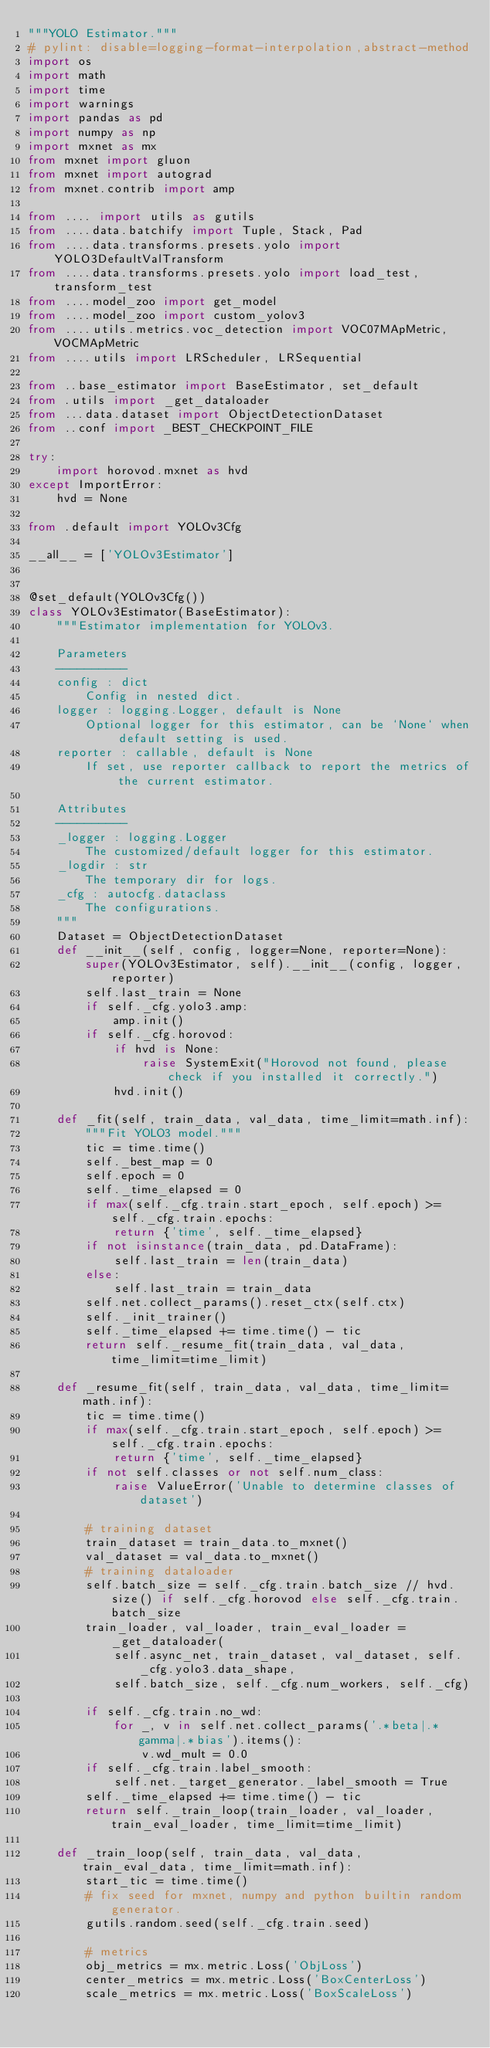<code> <loc_0><loc_0><loc_500><loc_500><_Python_>"""YOLO Estimator."""
# pylint: disable=logging-format-interpolation,abstract-method
import os
import math
import time
import warnings
import pandas as pd
import numpy as np
import mxnet as mx
from mxnet import gluon
from mxnet import autograd
from mxnet.contrib import amp

from .... import utils as gutils
from ....data.batchify import Tuple, Stack, Pad
from ....data.transforms.presets.yolo import YOLO3DefaultValTransform
from ....data.transforms.presets.yolo import load_test, transform_test
from ....model_zoo import get_model
from ....model_zoo import custom_yolov3
from ....utils.metrics.voc_detection import VOC07MApMetric, VOCMApMetric
from ....utils import LRScheduler, LRSequential

from ..base_estimator import BaseEstimator, set_default
from .utils import _get_dataloader
from ...data.dataset import ObjectDetectionDataset
from ..conf import _BEST_CHECKPOINT_FILE

try:
    import horovod.mxnet as hvd
except ImportError:
    hvd = None

from .default import YOLOv3Cfg

__all__ = ['YOLOv3Estimator']


@set_default(YOLOv3Cfg())
class YOLOv3Estimator(BaseEstimator):
    """Estimator implementation for YOLOv3.

    Parameters
    ----------
    config : dict
        Config in nested dict.
    logger : logging.Logger, default is None
        Optional logger for this estimator, can be `None` when default setting is used.
    reporter : callable, default is None
        If set, use reporter callback to report the metrics of the current estimator.

    Attributes
    ----------
    _logger : logging.Logger
        The customized/default logger for this estimator.
    _logdir : str
        The temporary dir for logs.
    _cfg : autocfg.dataclass
        The configurations.
    """
    Dataset = ObjectDetectionDataset
    def __init__(self, config, logger=None, reporter=None):
        super(YOLOv3Estimator, self).__init__(config, logger, reporter)
        self.last_train = None
        if self._cfg.yolo3.amp:
            amp.init()
        if self._cfg.horovod:
            if hvd is None:
                raise SystemExit("Horovod not found, please check if you installed it correctly.")
            hvd.init()

    def _fit(self, train_data, val_data, time_limit=math.inf):
        """Fit YOLO3 model."""
        tic = time.time()
        self._best_map = 0
        self.epoch = 0
        self._time_elapsed = 0
        if max(self._cfg.train.start_epoch, self.epoch) >= self._cfg.train.epochs:
            return {'time', self._time_elapsed}
        if not isinstance(train_data, pd.DataFrame):
            self.last_train = len(train_data)
        else:
            self.last_train = train_data
        self.net.collect_params().reset_ctx(self.ctx)
        self._init_trainer()
        self._time_elapsed += time.time() - tic
        return self._resume_fit(train_data, val_data, time_limit=time_limit)

    def _resume_fit(self, train_data, val_data, time_limit=math.inf):
        tic = time.time()
        if max(self._cfg.train.start_epoch, self.epoch) >= self._cfg.train.epochs:
            return {'time', self._time_elapsed}
        if not self.classes or not self.num_class:
            raise ValueError('Unable to determine classes of dataset')

        # training dataset
        train_dataset = train_data.to_mxnet()
        val_dataset = val_data.to_mxnet()
        # training dataloader
        self.batch_size = self._cfg.train.batch_size // hvd.size() if self._cfg.horovod else self._cfg.train.batch_size
        train_loader, val_loader, train_eval_loader = _get_dataloader(
            self.async_net, train_dataset, val_dataset, self._cfg.yolo3.data_shape,
            self.batch_size, self._cfg.num_workers, self._cfg)

        if self._cfg.train.no_wd:
            for _, v in self.net.collect_params('.*beta|.*gamma|.*bias').items():
                v.wd_mult = 0.0
        if self._cfg.train.label_smooth:
            self.net._target_generator._label_smooth = True
        self._time_elapsed += time.time() - tic
        return self._train_loop(train_loader, val_loader, train_eval_loader, time_limit=time_limit)

    def _train_loop(self, train_data, val_data, train_eval_data, time_limit=math.inf):
        start_tic = time.time()
        # fix seed for mxnet, numpy and python builtin random generator.
        gutils.random.seed(self._cfg.train.seed)

        # metrics
        obj_metrics = mx.metric.Loss('ObjLoss')
        center_metrics = mx.metric.Loss('BoxCenterLoss')
        scale_metrics = mx.metric.Loss('BoxScaleLoss')</code> 